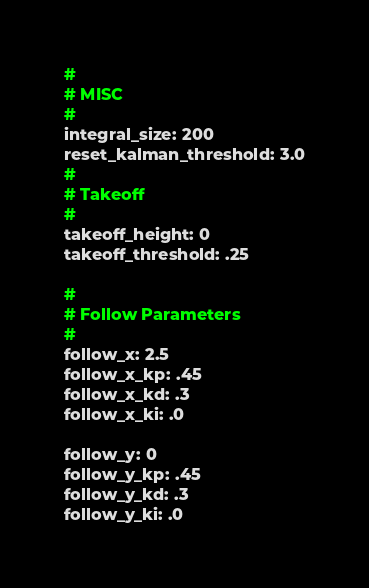Convert code to text. <code><loc_0><loc_0><loc_500><loc_500><_YAML_>#
# MISC
#
integral_size: 200
reset_kalman_threshold: 3.0
#
# Takeoff
#
takeoff_height: 0
takeoff_threshold: .25

#
# Follow Parameters
#
follow_x: 2.5
follow_x_kp: .45
follow_x_kd: .3
follow_x_ki: .0

follow_y: 0
follow_y_kp: .45
follow_y_kd: .3
follow_y_ki: .0
</code> 